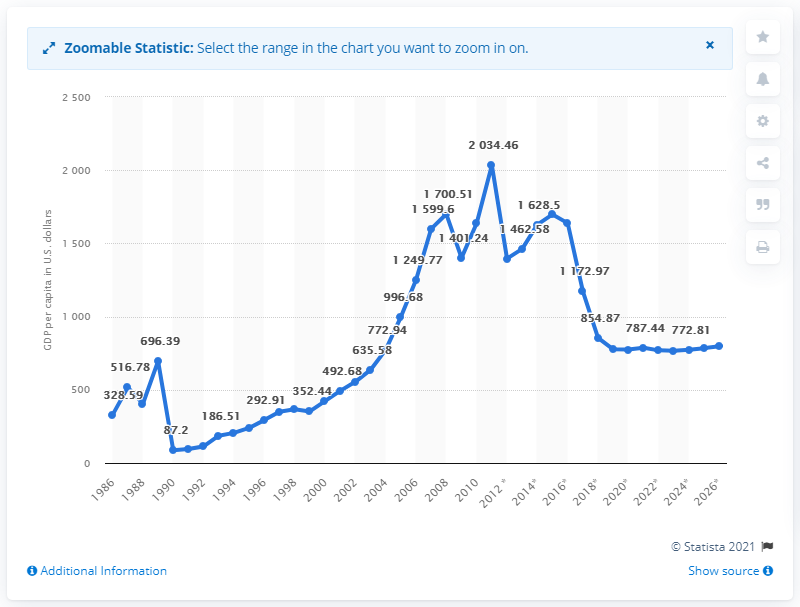Outline some significant characteristics in this image. The estimated GDP per capita in Sudan in 2020 was 775.04. 